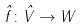<formula> <loc_0><loc_0><loc_500><loc_500>\hat { f } \colon \hat { V } \rightarrow W</formula> 